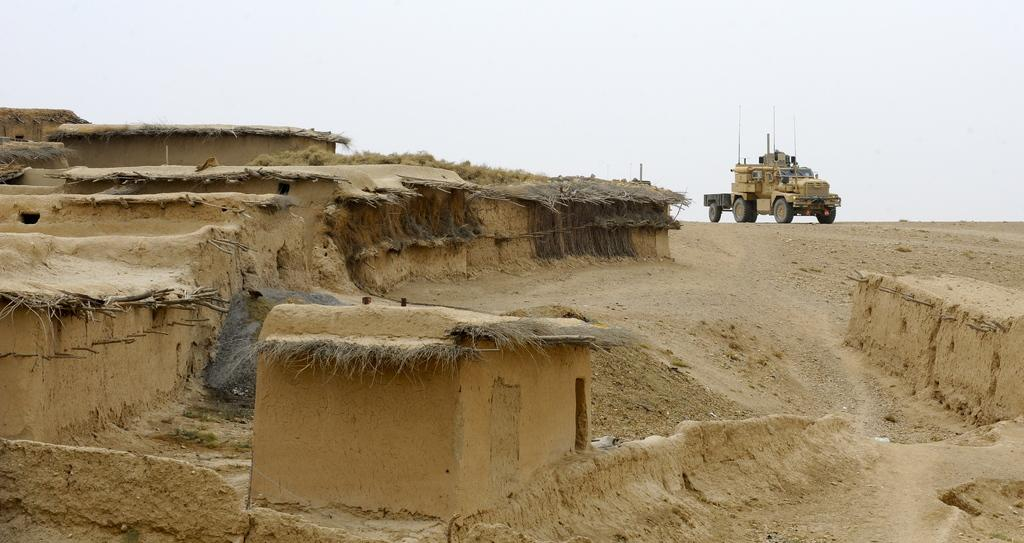What type of structures are present in the image? There are houses in the image. What is unique about the roof of one of the houses? There is a roof with grass in the image. What vehicle can be seen on the ground in the image? There is a truck on the ground in the image. What is visible at the top of the image? The sky is visible at the top of the image. Can you see any snails crawling on the glass in the image? There is no glass or snails present in the image. What type of cabbage is growing on the roof with grass in the image? There is no cabbage present on the roof with grass in the image. 